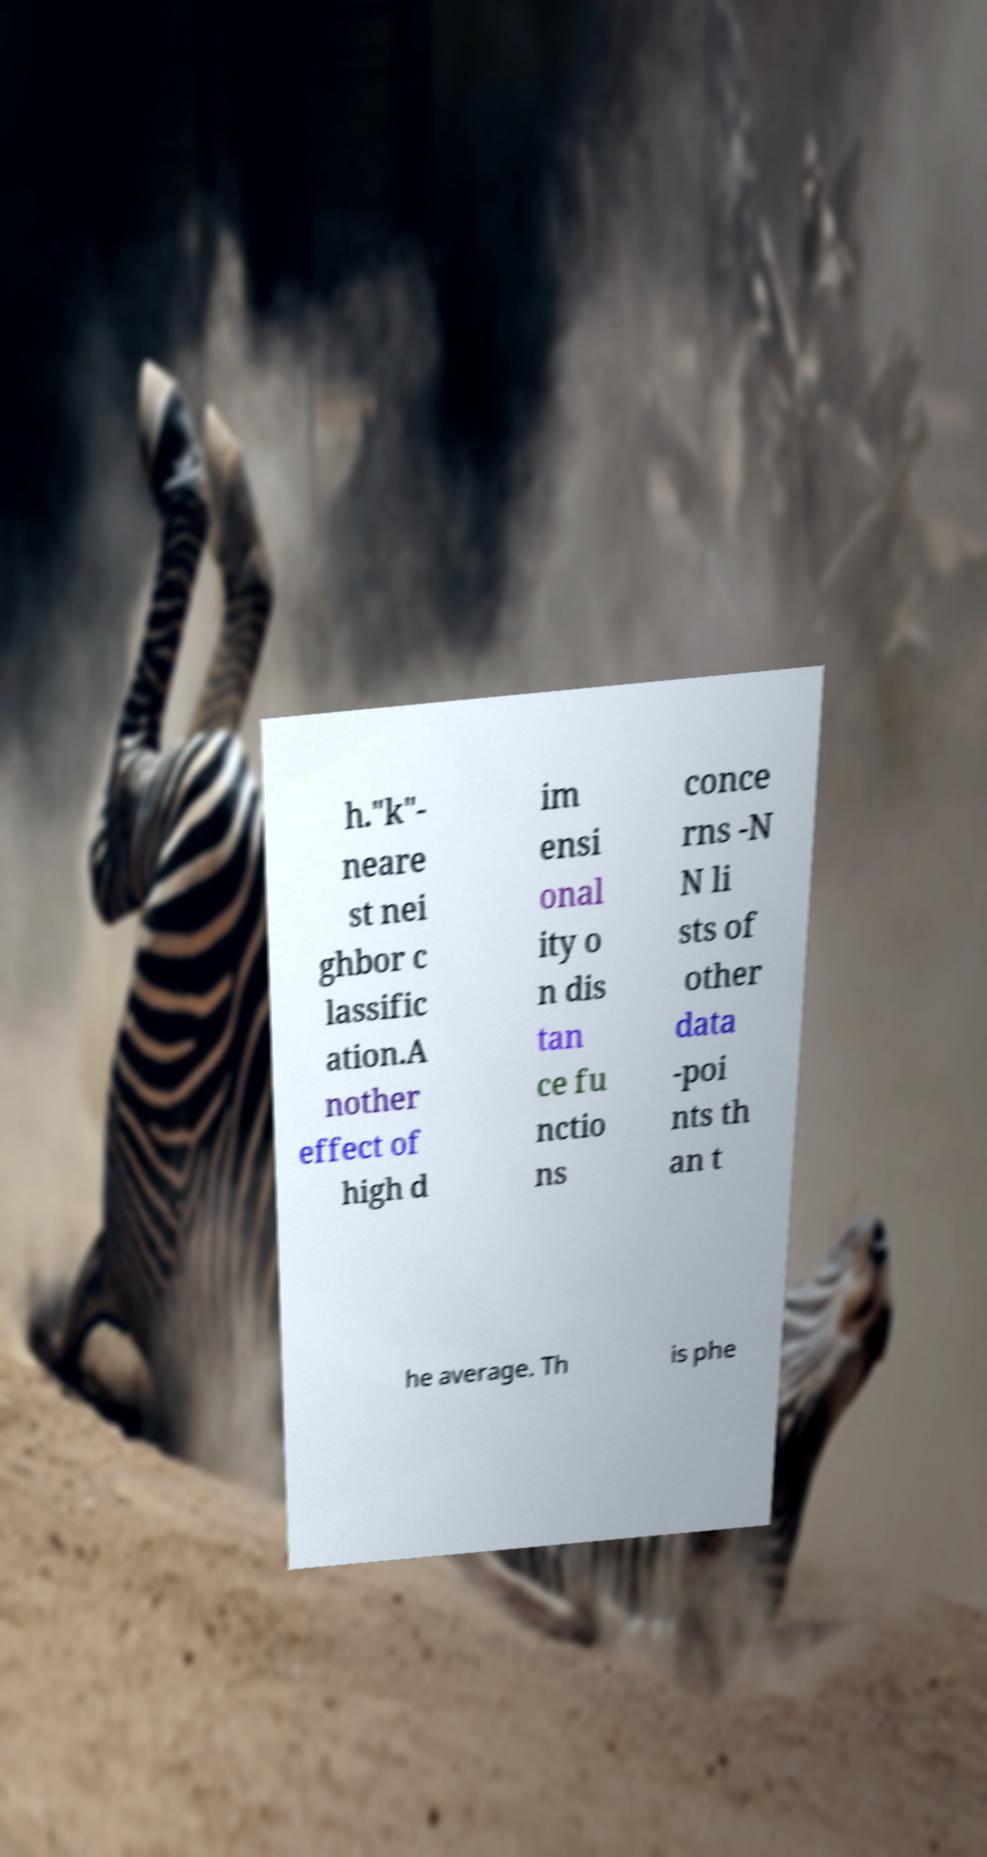Can you accurately transcribe the text from the provided image for me? h."k"- neare st nei ghbor c lassific ation.A nother effect of high d im ensi onal ity o n dis tan ce fu nctio ns conce rns -N N li sts of other data -poi nts th an t he average. Th is phe 